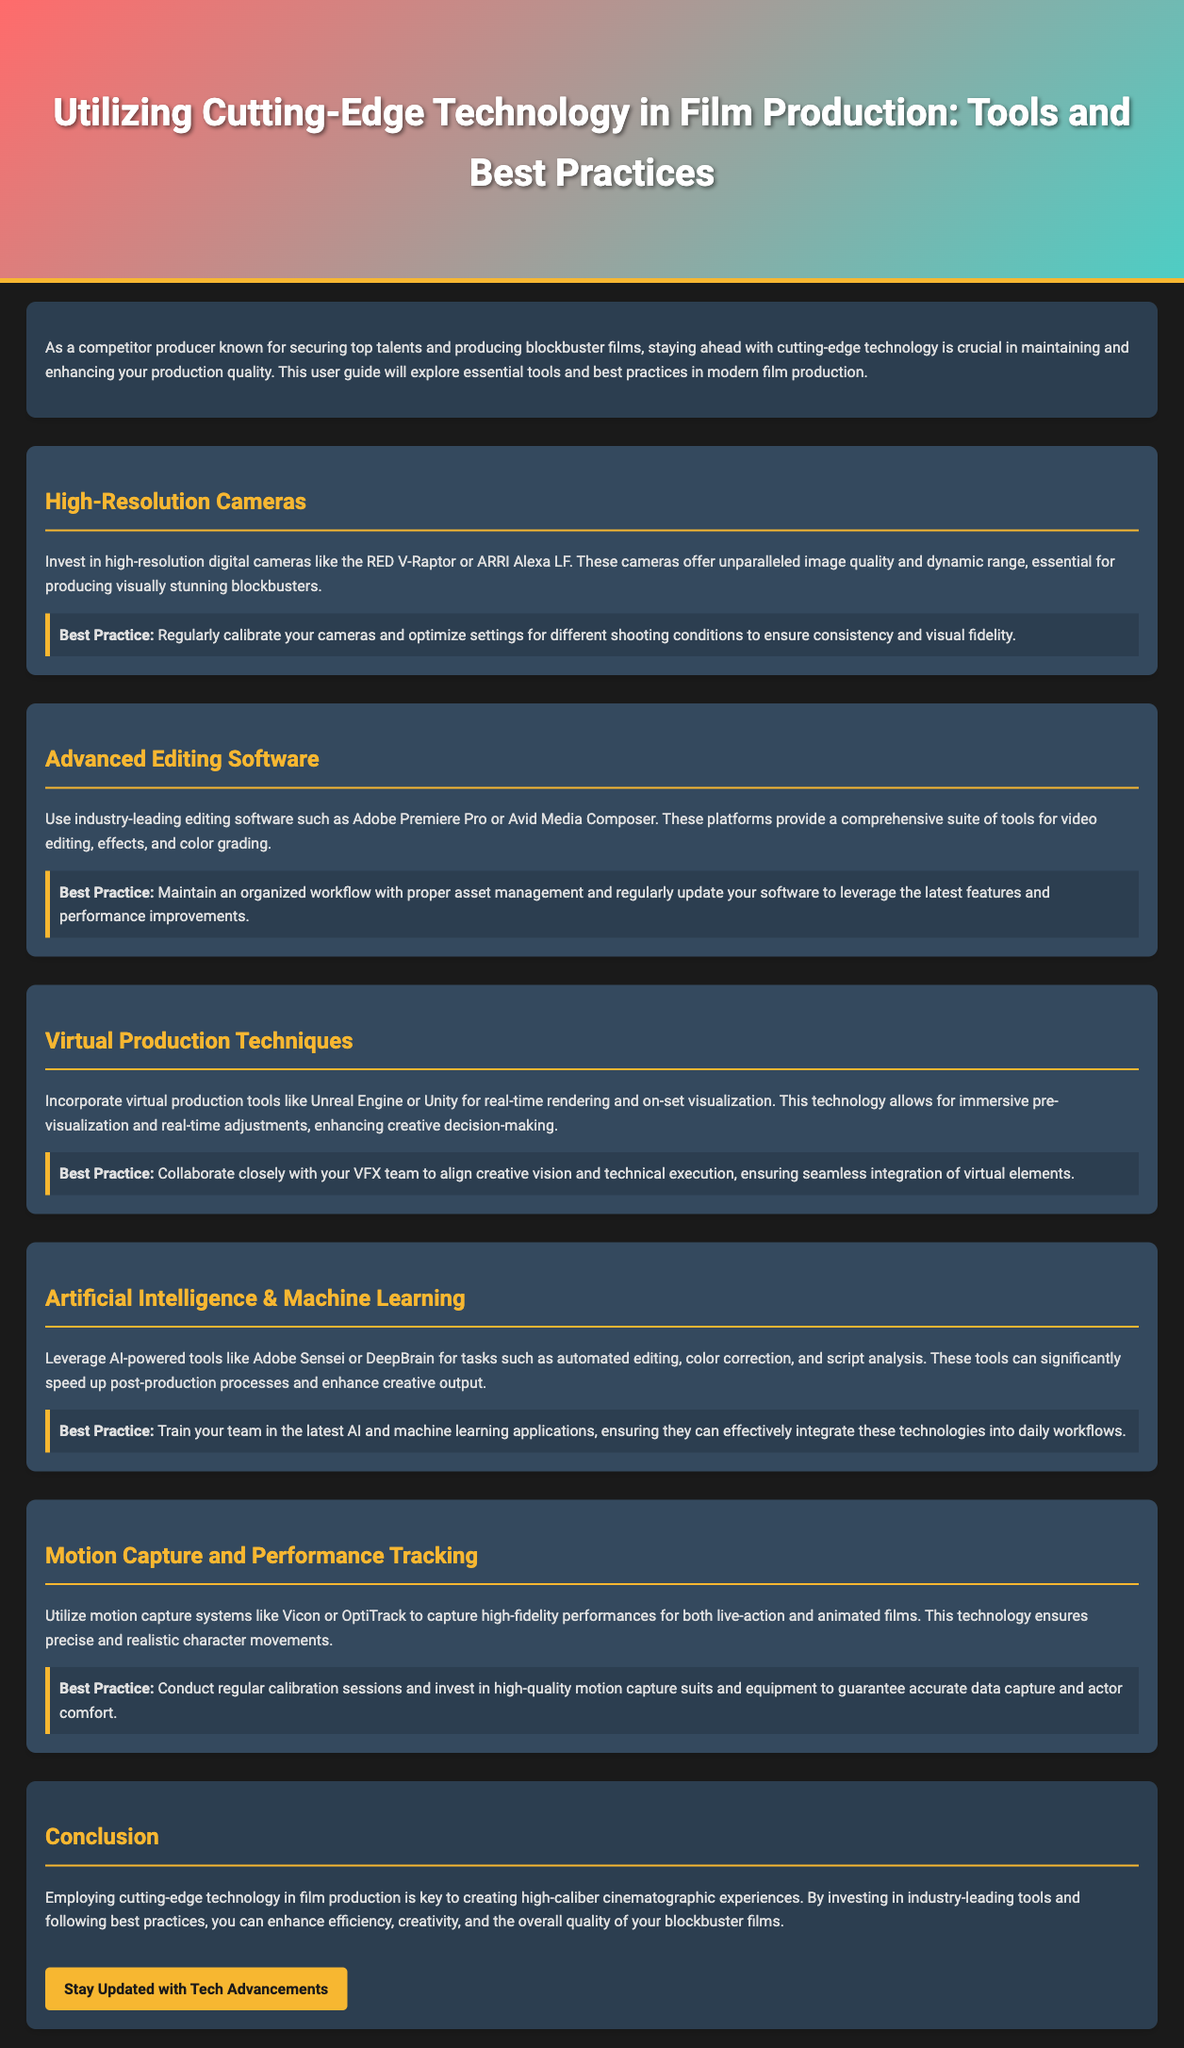What is the primary focus of the user guide? The primary focus of the user guide is to explore essential tools and best practices in modern film production using cutting-edge technology.
Answer: Essential tools and best practices in modern film production What high-resolution digital cameras are recommended? Recommended cameras mentioned in the document include the RED V-Raptor and ARRI Alexa LF.
Answer: RED V-Raptor or ARRI Alexa LF What editing software is suggested for film production? The suggested editing software for film production is Adobe Premiere Pro or Avid Media Composer.
Answer: Adobe Premiere Pro or Avid Media Composer What does the document recommend for virtual production tools? The document recommends using Unreal Engine or Unity for virtual production techniques.
Answer: Unreal Engine or Unity What is a best practice for using high-resolution cameras? A best practice includes regularly calibrating your cameras and optimizing settings for different shooting conditions.
Answer: Regularly calibrate your cameras What AI-powered tools are mentioned for post-production tasks? The AI-powered tools mentioned include Adobe Sensei and DeepBrain for tasks such as automated editing.
Answer: Adobe Sensei or DeepBrain What type of systems should be utilized for motion capture? The document suggests utilizing motion capture systems like Vicon or OptiTrack.
Answer: Vicon or OptiTrack What is emphasized as key to creating high-caliber cinematographic experiences? Employing cutting-edge technology in film production is emphasized as key to creating high-caliber cinematographic experiences.
Answer: Employing cutting-edge technology 